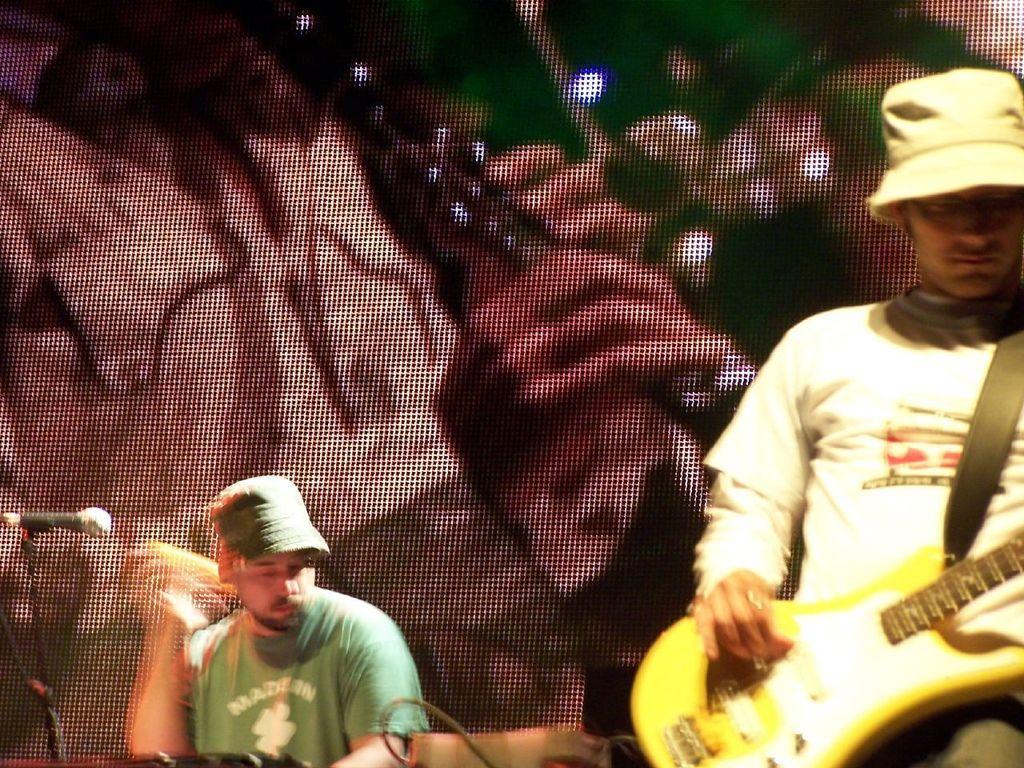How would you summarize this image in a sentence or two? A man is playing a guitar in the front. Another man is playing drums in the background. 